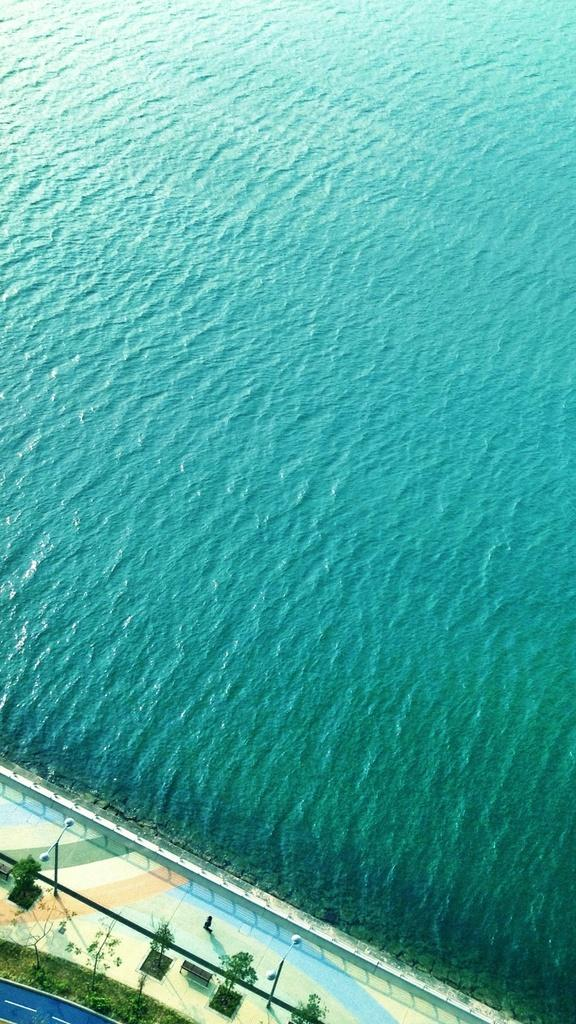What is present at the bottom of the image? There is a floor at the bottom of the image. What can be seen in the image besides the floor? There is water, plants, and poles visible in the image. Can you describe the plants in the image? The plants in the image are not specified, but they are present. What type of ground can be seen in the image? There is no ground visible in the image; it features water, a floor, plants, and poles. How does the spade help in the journey depicted in the image? There is no journey or spade present in the image. 